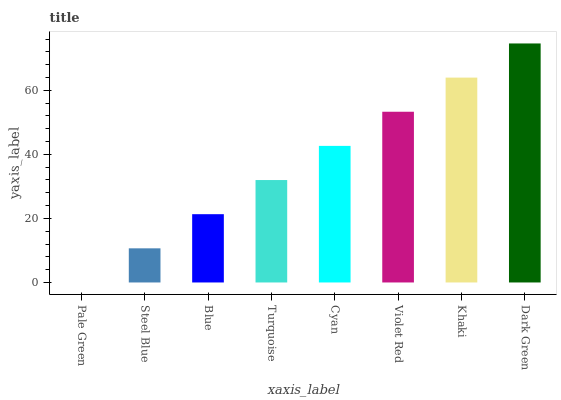Is Pale Green the minimum?
Answer yes or no. Yes. Is Dark Green the maximum?
Answer yes or no. Yes. Is Steel Blue the minimum?
Answer yes or no. No. Is Steel Blue the maximum?
Answer yes or no. No. Is Steel Blue greater than Pale Green?
Answer yes or no. Yes. Is Pale Green less than Steel Blue?
Answer yes or no. Yes. Is Pale Green greater than Steel Blue?
Answer yes or no. No. Is Steel Blue less than Pale Green?
Answer yes or no. No. Is Cyan the high median?
Answer yes or no. Yes. Is Turquoise the low median?
Answer yes or no. Yes. Is Dark Green the high median?
Answer yes or no. No. Is Dark Green the low median?
Answer yes or no. No. 